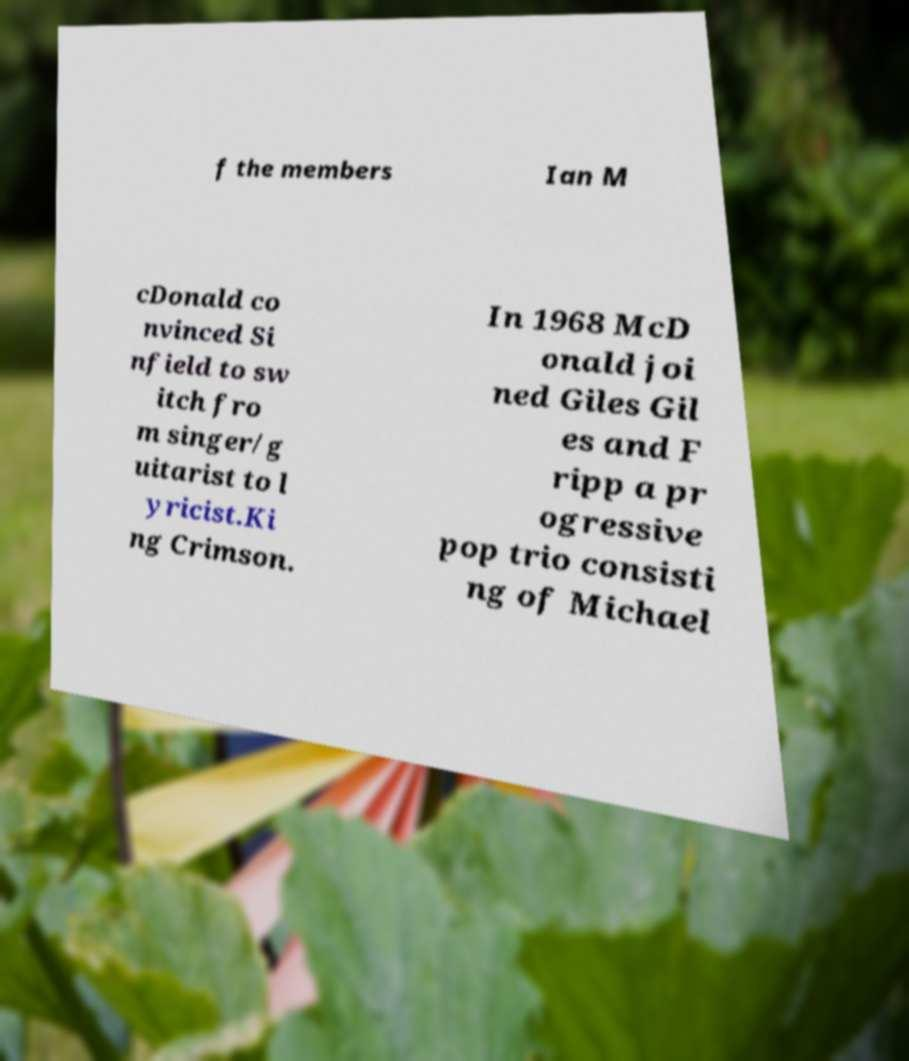Could you extract and type out the text from this image? f the members Ian M cDonald co nvinced Si nfield to sw itch fro m singer/g uitarist to l yricist.Ki ng Crimson. In 1968 McD onald joi ned Giles Gil es and F ripp a pr ogressive pop trio consisti ng of Michael 